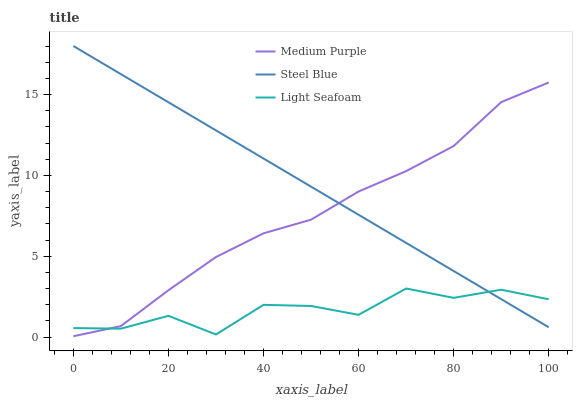Does Light Seafoam have the minimum area under the curve?
Answer yes or no. Yes. Does Steel Blue have the maximum area under the curve?
Answer yes or no. Yes. Does Steel Blue have the minimum area under the curve?
Answer yes or no. No. Does Light Seafoam have the maximum area under the curve?
Answer yes or no. No. Is Steel Blue the smoothest?
Answer yes or no. Yes. Is Light Seafoam the roughest?
Answer yes or no. Yes. Is Light Seafoam the smoothest?
Answer yes or no. No. Is Steel Blue the roughest?
Answer yes or no. No. Does Medium Purple have the lowest value?
Answer yes or no. Yes. Does Light Seafoam have the lowest value?
Answer yes or no. No. Does Steel Blue have the highest value?
Answer yes or no. Yes. Does Light Seafoam have the highest value?
Answer yes or no. No. Does Medium Purple intersect Steel Blue?
Answer yes or no. Yes. Is Medium Purple less than Steel Blue?
Answer yes or no. No. Is Medium Purple greater than Steel Blue?
Answer yes or no. No. 